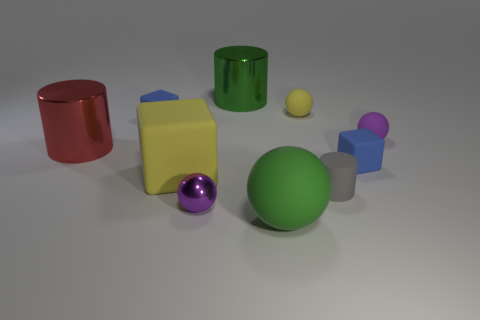There is a rubber ball right of the gray rubber object; how many big green objects are on the right side of it?
Keep it short and to the point. 0. What size is the cube in front of the blue rubber object right of the big matte thing that is in front of the tiny gray cylinder?
Give a very brief answer. Large. The tiny rubber cube behind the small purple ball that is behind the tiny metallic object is what color?
Your response must be concise. Blue. What number of other objects are the same material as the tiny gray thing?
Offer a very short reply. 6. How many other objects are the same color as the tiny cylinder?
Keep it short and to the point. 0. The small blue thing in front of the tiny blue rubber thing behind the purple rubber ball is made of what material?
Your response must be concise. Rubber. Are any tiny gray metallic cylinders visible?
Offer a very short reply. No. How big is the red thing that is on the left side of the matte block on the right side of the green shiny object?
Make the answer very short. Large. Is the number of tiny purple balls behind the small gray cylinder greater than the number of small gray cylinders in front of the green matte ball?
Your response must be concise. Yes. What number of cubes are either small objects or small purple matte objects?
Your answer should be very brief. 2. 